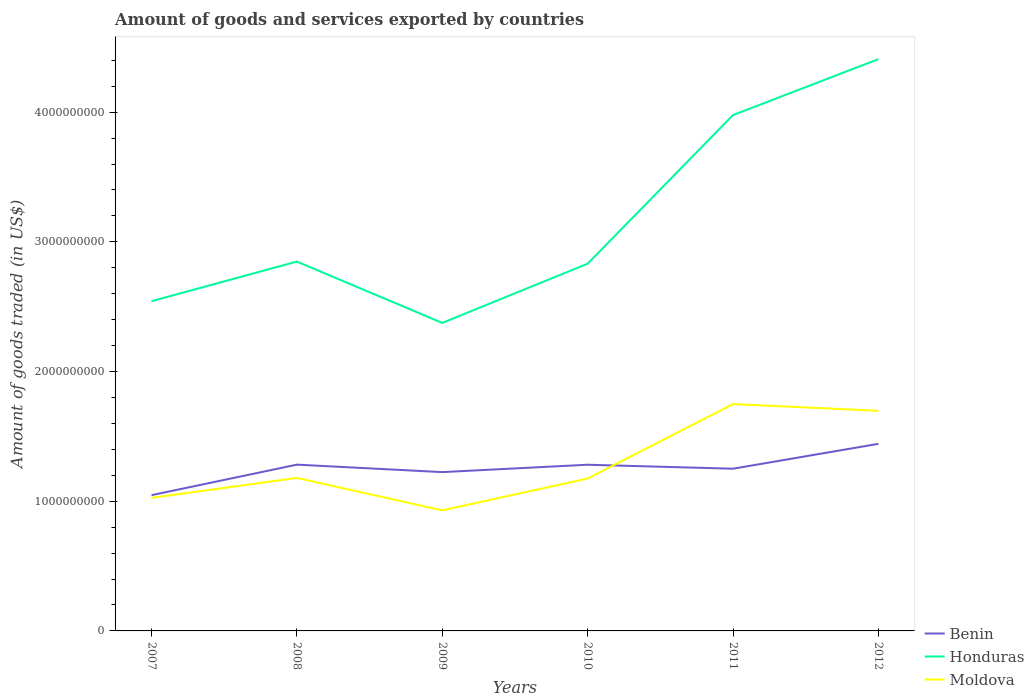How many different coloured lines are there?
Your answer should be compact. 3. Is the number of lines equal to the number of legend labels?
Provide a succinct answer. Yes. Across all years, what is the maximum total amount of goods and services exported in Benin?
Keep it short and to the point. 1.05e+09. In which year was the total amount of goods and services exported in Benin maximum?
Your answer should be very brief. 2007. What is the total total amount of goods and services exported in Moldova in the graph?
Provide a succinct answer. -2.45e+08. What is the difference between the highest and the second highest total amount of goods and services exported in Moldova?
Make the answer very short. 8.20e+08. What is the difference between the highest and the lowest total amount of goods and services exported in Moldova?
Make the answer very short. 2. How many lines are there?
Make the answer very short. 3. How many years are there in the graph?
Make the answer very short. 6. What is the difference between two consecutive major ticks on the Y-axis?
Your answer should be very brief. 1.00e+09. Where does the legend appear in the graph?
Your answer should be compact. Bottom right. How many legend labels are there?
Keep it short and to the point. 3. How are the legend labels stacked?
Make the answer very short. Vertical. What is the title of the graph?
Provide a succinct answer. Amount of goods and services exported by countries. What is the label or title of the X-axis?
Make the answer very short. Years. What is the label or title of the Y-axis?
Provide a succinct answer. Amount of goods traded (in US$). What is the Amount of goods traded (in US$) in Benin in 2007?
Keep it short and to the point. 1.05e+09. What is the Amount of goods traded (in US$) in Honduras in 2007?
Your answer should be very brief. 2.54e+09. What is the Amount of goods traded (in US$) in Moldova in 2007?
Give a very brief answer. 1.03e+09. What is the Amount of goods traded (in US$) of Benin in 2008?
Provide a succinct answer. 1.28e+09. What is the Amount of goods traded (in US$) in Honduras in 2008?
Make the answer very short. 2.85e+09. What is the Amount of goods traded (in US$) of Moldova in 2008?
Make the answer very short. 1.18e+09. What is the Amount of goods traded (in US$) in Benin in 2009?
Your answer should be compact. 1.22e+09. What is the Amount of goods traded (in US$) of Honduras in 2009?
Offer a terse response. 2.38e+09. What is the Amount of goods traded (in US$) of Moldova in 2009?
Make the answer very short. 9.30e+08. What is the Amount of goods traded (in US$) in Benin in 2010?
Your answer should be very brief. 1.28e+09. What is the Amount of goods traded (in US$) in Honduras in 2010?
Ensure brevity in your answer.  2.83e+09. What is the Amount of goods traded (in US$) of Moldova in 2010?
Your response must be concise. 1.18e+09. What is the Amount of goods traded (in US$) of Benin in 2011?
Provide a succinct answer. 1.25e+09. What is the Amount of goods traded (in US$) in Honduras in 2011?
Give a very brief answer. 3.98e+09. What is the Amount of goods traded (in US$) of Moldova in 2011?
Offer a terse response. 1.75e+09. What is the Amount of goods traded (in US$) of Benin in 2012?
Your response must be concise. 1.44e+09. What is the Amount of goods traded (in US$) of Honduras in 2012?
Offer a very short reply. 4.41e+09. What is the Amount of goods traded (in US$) of Moldova in 2012?
Offer a very short reply. 1.70e+09. Across all years, what is the maximum Amount of goods traded (in US$) of Benin?
Provide a succinct answer. 1.44e+09. Across all years, what is the maximum Amount of goods traded (in US$) in Honduras?
Ensure brevity in your answer.  4.41e+09. Across all years, what is the maximum Amount of goods traded (in US$) of Moldova?
Your answer should be compact. 1.75e+09. Across all years, what is the minimum Amount of goods traded (in US$) in Benin?
Your answer should be compact. 1.05e+09. Across all years, what is the minimum Amount of goods traded (in US$) of Honduras?
Keep it short and to the point. 2.38e+09. Across all years, what is the minimum Amount of goods traded (in US$) of Moldova?
Ensure brevity in your answer.  9.30e+08. What is the total Amount of goods traded (in US$) of Benin in the graph?
Your response must be concise. 7.53e+09. What is the total Amount of goods traded (in US$) of Honduras in the graph?
Provide a short and direct response. 1.90e+1. What is the total Amount of goods traded (in US$) in Moldova in the graph?
Keep it short and to the point. 7.76e+09. What is the difference between the Amount of goods traded (in US$) of Benin in 2007 and that in 2008?
Your answer should be very brief. -2.35e+08. What is the difference between the Amount of goods traded (in US$) of Honduras in 2007 and that in 2008?
Your answer should be very brief. -3.05e+08. What is the difference between the Amount of goods traded (in US$) in Moldova in 2007 and that in 2008?
Your answer should be compact. -1.54e+08. What is the difference between the Amount of goods traded (in US$) of Benin in 2007 and that in 2009?
Provide a short and direct response. -1.78e+08. What is the difference between the Amount of goods traded (in US$) in Honduras in 2007 and that in 2009?
Give a very brief answer. 1.68e+08. What is the difference between the Amount of goods traded (in US$) of Moldova in 2007 and that in 2009?
Your answer should be very brief. 9.62e+07. What is the difference between the Amount of goods traded (in US$) of Benin in 2007 and that in 2010?
Make the answer very short. -2.35e+08. What is the difference between the Amount of goods traded (in US$) of Honduras in 2007 and that in 2010?
Ensure brevity in your answer.  -2.89e+08. What is the difference between the Amount of goods traded (in US$) in Moldova in 2007 and that in 2010?
Make the answer very short. -1.49e+08. What is the difference between the Amount of goods traded (in US$) in Benin in 2007 and that in 2011?
Your answer should be compact. -2.04e+08. What is the difference between the Amount of goods traded (in US$) of Honduras in 2007 and that in 2011?
Offer a terse response. -1.43e+09. What is the difference between the Amount of goods traded (in US$) of Moldova in 2007 and that in 2011?
Ensure brevity in your answer.  -7.23e+08. What is the difference between the Amount of goods traded (in US$) in Benin in 2007 and that in 2012?
Your answer should be compact. -3.96e+08. What is the difference between the Amount of goods traded (in US$) of Honduras in 2007 and that in 2012?
Ensure brevity in your answer.  -1.87e+09. What is the difference between the Amount of goods traded (in US$) of Moldova in 2007 and that in 2012?
Provide a short and direct response. -6.71e+08. What is the difference between the Amount of goods traded (in US$) in Benin in 2008 and that in 2009?
Your answer should be very brief. 5.76e+07. What is the difference between the Amount of goods traded (in US$) in Honduras in 2008 and that in 2009?
Your answer should be very brief. 4.73e+08. What is the difference between the Amount of goods traded (in US$) of Moldova in 2008 and that in 2009?
Offer a terse response. 2.50e+08. What is the difference between the Amount of goods traded (in US$) in Benin in 2008 and that in 2010?
Provide a succinct answer. 6.49e+05. What is the difference between the Amount of goods traded (in US$) in Honduras in 2008 and that in 2010?
Make the answer very short. 1.64e+07. What is the difference between the Amount of goods traded (in US$) in Moldova in 2008 and that in 2010?
Offer a terse response. 4.72e+06. What is the difference between the Amount of goods traded (in US$) in Benin in 2008 and that in 2011?
Provide a short and direct response. 3.14e+07. What is the difference between the Amount of goods traded (in US$) in Honduras in 2008 and that in 2011?
Your response must be concise. -1.13e+09. What is the difference between the Amount of goods traded (in US$) of Moldova in 2008 and that in 2011?
Give a very brief answer. -5.70e+08. What is the difference between the Amount of goods traded (in US$) in Benin in 2008 and that in 2012?
Provide a succinct answer. -1.60e+08. What is the difference between the Amount of goods traded (in US$) of Honduras in 2008 and that in 2012?
Keep it short and to the point. -1.56e+09. What is the difference between the Amount of goods traded (in US$) of Moldova in 2008 and that in 2012?
Offer a very short reply. -5.18e+08. What is the difference between the Amount of goods traded (in US$) of Benin in 2009 and that in 2010?
Provide a short and direct response. -5.70e+07. What is the difference between the Amount of goods traded (in US$) of Honduras in 2009 and that in 2010?
Offer a very short reply. -4.57e+08. What is the difference between the Amount of goods traded (in US$) of Moldova in 2009 and that in 2010?
Keep it short and to the point. -2.45e+08. What is the difference between the Amount of goods traded (in US$) of Benin in 2009 and that in 2011?
Make the answer very short. -2.62e+07. What is the difference between the Amount of goods traded (in US$) in Honduras in 2009 and that in 2011?
Your response must be concise. -1.60e+09. What is the difference between the Amount of goods traded (in US$) in Moldova in 2009 and that in 2011?
Your answer should be very brief. -8.20e+08. What is the difference between the Amount of goods traded (in US$) in Benin in 2009 and that in 2012?
Make the answer very short. -2.18e+08. What is the difference between the Amount of goods traded (in US$) of Honduras in 2009 and that in 2012?
Give a very brief answer. -2.03e+09. What is the difference between the Amount of goods traded (in US$) in Moldova in 2009 and that in 2012?
Give a very brief answer. -7.67e+08. What is the difference between the Amount of goods traded (in US$) of Benin in 2010 and that in 2011?
Keep it short and to the point. 3.07e+07. What is the difference between the Amount of goods traded (in US$) of Honduras in 2010 and that in 2011?
Keep it short and to the point. -1.15e+09. What is the difference between the Amount of goods traded (in US$) in Moldova in 2010 and that in 2011?
Provide a short and direct response. -5.74e+08. What is the difference between the Amount of goods traded (in US$) in Benin in 2010 and that in 2012?
Offer a terse response. -1.61e+08. What is the difference between the Amount of goods traded (in US$) in Honduras in 2010 and that in 2012?
Offer a terse response. -1.58e+09. What is the difference between the Amount of goods traded (in US$) in Moldova in 2010 and that in 2012?
Ensure brevity in your answer.  -5.22e+08. What is the difference between the Amount of goods traded (in US$) of Benin in 2011 and that in 2012?
Offer a very short reply. -1.92e+08. What is the difference between the Amount of goods traded (in US$) in Honduras in 2011 and that in 2012?
Keep it short and to the point. -4.32e+08. What is the difference between the Amount of goods traded (in US$) in Moldova in 2011 and that in 2012?
Give a very brief answer. 5.22e+07. What is the difference between the Amount of goods traded (in US$) of Benin in 2007 and the Amount of goods traded (in US$) of Honduras in 2008?
Keep it short and to the point. -1.80e+09. What is the difference between the Amount of goods traded (in US$) in Benin in 2007 and the Amount of goods traded (in US$) in Moldova in 2008?
Make the answer very short. -1.33e+08. What is the difference between the Amount of goods traded (in US$) of Honduras in 2007 and the Amount of goods traded (in US$) of Moldova in 2008?
Your answer should be compact. 1.36e+09. What is the difference between the Amount of goods traded (in US$) of Benin in 2007 and the Amount of goods traded (in US$) of Honduras in 2009?
Your answer should be compact. -1.33e+09. What is the difference between the Amount of goods traded (in US$) in Benin in 2007 and the Amount of goods traded (in US$) in Moldova in 2009?
Offer a very short reply. 1.17e+08. What is the difference between the Amount of goods traded (in US$) of Honduras in 2007 and the Amount of goods traded (in US$) of Moldova in 2009?
Ensure brevity in your answer.  1.61e+09. What is the difference between the Amount of goods traded (in US$) in Benin in 2007 and the Amount of goods traded (in US$) in Honduras in 2010?
Give a very brief answer. -1.78e+09. What is the difference between the Amount of goods traded (in US$) of Benin in 2007 and the Amount of goods traded (in US$) of Moldova in 2010?
Your answer should be compact. -1.28e+08. What is the difference between the Amount of goods traded (in US$) in Honduras in 2007 and the Amount of goods traded (in US$) in Moldova in 2010?
Keep it short and to the point. 1.37e+09. What is the difference between the Amount of goods traded (in US$) of Benin in 2007 and the Amount of goods traded (in US$) of Honduras in 2011?
Give a very brief answer. -2.93e+09. What is the difference between the Amount of goods traded (in US$) in Benin in 2007 and the Amount of goods traded (in US$) in Moldova in 2011?
Make the answer very short. -7.03e+08. What is the difference between the Amount of goods traded (in US$) in Honduras in 2007 and the Amount of goods traded (in US$) in Moldova in 2011?
Provide a succinct answer. 7.93e+08. What is the difference between the Amount of goods traded (in US$) of Benin in 2007 and the Amount of goods traded (in US$) of Honduras in 2012?
Offer a very short reply. -3.36e+09. What is the difference between the Amount of goods traded (in US$) in Benin in 2007 and the Amount of goods traded (in US$) in Moldova in 2012?
Your answer should be very brief. -6.51e+08. What is the difference between the Amount of goods traded (in US$) of Honduras in 2007 and the Amount of goods traded (in US$) of Moldova in 2012?
Provide a succinct answer. 8.45e+08. What is the difference between the Amount of goods traded (in US$) in Benin in 2008 and the Amount of goods traded (in US$) in Honduras in 2009?
Provide a succinct answer. -1.09e+09. What is the difference between the Amount of goods traded (in US$) of Benin in 2008 and the Amount of goods traded (in US$) of Moldova in 2009?
Keep it short and to the point. 3.52e+08. What is the difference between the Amount of goods traded (in US$) of Honduras in 2008 and the Amount of goods traded (in US$) of Moldova in 2009?
Make the answer very short. 1.92e+09. What is the difference between the Amount of goods traded (in US$) in Benin in 2008 and the Amount of goods traded (in US$) in Honduras in 2010?
Your answer should be very brief. -1.55e+09. What is the difference between the Amount of goods traded (in US$) of Benin in 2008 and the Amount of goods traded (in US$) of Moldova in 2010?
Make the answer very short. 1.07e+08. What is the difference between the Amount of goods traded (in US$) of Honduras in 2008 and the Amount of goods traded (in US$) of Moldova in 2010?
Provide a succinct answer. 1.67e+09. What is the difference between the Amount of goods traded (in US$) in Benin in 2008 and the Amount of goods traded (in US$) in Honduras in 2011?
Keep it short and to the point. -2.70e+09. What is the difference between the Amount of goods traded (in US$) in Benin in 2008 and the Amount of goods traded (in US$) in Moldova in 2011?
Provide a succinct answer. -4.67e+08. What is the difference between the Amount of goods traded (in US$) of Honduras in 2008 and the Amount of goods traded (in US$) of Moldova in 2011?
Provide a short and direct response. 1.10e+09. What is the difference between the Amount of goods traded (in US$) of Benin in 2008 and the Amount of goods traded (in US$) of Honduras in 2012?
Make the answer very short. -3.13e+09. What is the difference between the Amount of goods traded (in US$) of Benin in 2008 and the Amount of goods traded (in US$) of Moldova in 2012?
Your response must be concise. -4.15e+08. What is the difference between the Amount of goods traded (in US$) in Honduras in 2008 and the Amount of goods traded (in US$) in Moldova in 2012?
Your answer should be compact. 1.15e+09. What is the difference between the Amount of goods traded (in US$) of Benin in 2009 and the Amount of goods traded (in US$) of Honduras in 2010?
Your answer should be compact. -1.61e+09. What is the difference between the Amount of goods traded (in US$) of Benin in 2009 and the Amount of goods traded (in US$) of Moldova in 2010?
Ensure brevity in your answer.  4.96e+07. What is the difference between the Amount of goods traded (in US$) in Honduras in 2009 and the Amount of goods traded (in US$) in Moldova in 2010?
Your answer should be compact. 1.20e+09. What is the difference between the Amount of goods traded (in US$) in Benin in 2009 and the Amount of goods traded (in US$) in Honduras in 2011?
Ensure brevity in your answer.  -2.75e+09. What is the difference between the Amount of goods traded (in US$) of Benin in 2009 and the Amount of goods traded (in US$) of Moldova in 2011?
Your answer should be compact. -5.25e+08. What is the difference between the Amount of goods traded (in US$) in Honduras in 2009 and the Amount of goods traded (in US$) in Moldova in 2011?
Provide a short and direct response. 6.26e+08. What is the difference between the Amount of goods traded (in US$) in Benin in 2009 and the Amount of goods traded (in US$) in Honduras in 2012?
Your answer should be very brief. -3.18e+09. What is the difference between the Amount of goods traded (in US$) in Benin in 2009 and the Amount of goods traded (in US$) in Moldova in 2012?
Offer a terse response. -4.73e+08. What is the difference between the Amount of goods traded (in US$) of Honduras in 2009 and the Amount of goods traded (in US$) of Moldova in 2012?
Your answer should be very brief. 6.78e+08. What is the difference between the Amount of goods traded (in US$) in Benin in 2010 and the Amount of goods traded (in US$) in Honduras in 2011?
Offer a very short reply. -2.70e+09. What is the difference between the Amount of goods traded (in US$) of Benin in 2010 and the Amount of goods traded (in US$) of Moldova in 2011?
Give a very brief answer. -4.68e+08. What is the difference between the Amount of goods traded (in US$) in Honduras in 2010 and the Amount of goods traded (in US$) in Moldova in 2011?
Provide a succinct answer. 1.08e+09. What is the difference between the Amount of goods traded (in US$) of Benin in 2010 and the Amount of goods traded (in US$) of Honduras in 2012?
Your response must be concise. -3.13e+09. What is the difference between the Amount of goods traded (in US$) of Benin in 2010 and the Amount of goods traded (in US$) of Moldova in 2012?
Offer a terse response. -4.16e+08. What is the difference between the Amount of goods traded (in US$) of Honduras in 2010 and the Amount of goods traded (in US$) of Moldova in 2012?
Keep it short and to the point. 1.13e+09. What is the difference between the Amount of goods traded (in US$) in Benin in 2011 and the Amount of goods traded (in US$) in Honduras in 2012?
Give a very brief answer. -3.16e+09. What is the difference between the Amount of goods traded (in US$) of Benin in 2011 and the Amount of goods traded (in US$) of Moldova in 2012?
Provide a succinct answer. -4.46e+08. What is the difference between the Amount of goods traded (in US$) in Honduras in 2011 and the Amount of goods traded (in US$) in Moldova in 2012?
Make the answer very short. 2.28e+09. What is the average Amount of goods traded (in US$) of Benin per year?
Ensure brevity in your answer.  1.25e+09. What is the average Amount of goods traded (in US$) of Honduras per year?
Give a very brief answer. 3.16e+09. What is the average Amount of goods traded (in US$) in Moldova per year?
Your response must be concise. 1.29e+09. In the year 2007, what is the difference between the Amount of goods traded (in US$) in Benin and Amount of goods traded (in US$) in Honduras?
Provide a succinct answer. -1.50e+09. In the year 2007, what is the difference between the Amount of goods traded (in US$) in Benin and Amount of goods traded (in US$) in Moldova?
Offer a very short reply. 2.08e+07. In the year 2007, what is the difference between the Amount of goods traded (in US$) of Honduras and Amount of goods traded (in US$) of Moldova?
Make the answer very short. 1.52e+09. In the year 2008, what is the difference between the Amount of goods traded (in US$) of Benin and Amount of goods traded (in US$) of Honduras?
Ensure brevity in your answer.  -1.57e+09. In the year 2008, what is the difference between the Amount of goods traded (in US$) of Benin and Amount of goods traded (in US$) of Moldova?
Provide a short and direct response. 1.02e+08. In the year 2008, what is the difference between the Amount of goods traded (in US$) of Honduras and Amount of goods traded (in US$) of Moldova?
Provide a short and direct response. 1.67e+09. In the year 2009, what is the difference between the Amount of goods traded (in US$) of Benin and Amount of goods traded (in US$) of Honduras?
Ensure brevity in your answer.  -1.15e+09. In the year 2009, what is the difference between the Amount of goods traded (in US$) in Benin and Amount of goods traded (in US$) in Moldova?
Provide a short and direct response. 2.95e+08. In the year 2009, what is the difference between the Amount of goods traded (in US$) in Honduras and Amount of goods traded (in US$) in Moldova?
Keep it short and to the point. 1.45e+09. In the year 2010, what is the difference between the Amount of goods traded (in US$) in Benin and Amount of goods traded (in US$) in Honduras?
Provide a succinct answer. -1.55e+09. In the year 2010, what is the difference between the Amount of goods traded (in US$) in Benin and Amount of goods traded (in US$) in Moldova?
Give a very brief answer. 1.07e+08. In the year 2010, what is the difference between the Amount of goods traded (in US$) of Honduras and Amount of goods traded (in US$) of Moldova?
Provide a short and direct response. 1.66e+09. In the year 2011, what is the difference between the Amount of goods traded (in US$) of Benin and Amount of goods traded (in US$) of Honduras?
Ensure brevity in your answer.  -2.73e+09. In the year 2011, what is the difference between the Amount of goods traded (in US$) in Benin and Amount of goods traded (in US$) in Moldova?
Provide a succinct answer. -4.99e+08. In the year 2011, what is the difference between the Amount of goods traded (in US$) in Honduras and Amount of goods traded (in US$) in Moldova?
Provide a succinct answer. 2.23e+09. In the year 2012, what is the difference between the Amount of goods traded (in US$) of Benin and Amount of goods traded (in US$) of Honduras?
Your answer should be very brief. -2.97e+09. In the year 2012, what is the difference between the Amount of goods traded (in US$) in Benin and Amount of goods traded (in US$) in Moldova?
Provide a short and direct response. -2.55e+08. In the year 2012, what is the difference between the Amount of goods traded (in US$) of Honduras and Amount of goods traded (in US$) of Moldova?
Make the answer very short. 2.71e+09. What is the ratio of the Amount of goods traded (in US$) in Benin in 2007 to that in 2008?
Make the answer very short. 0.82. What is the ratio of the Amount of goods traded (in US$) in Honduras in 2007 to that in 2008?
Your answer should be very brief. 0.89. What is the ratio of the Amount of goods traded (in US$) in Moldova in 2007 to that in 2008?
Offer a very short reply. 0.87. What is the ratio of the Amount of goods traded (in US$) of Benin in 2007 to that in 2009?
Offer a terse response. 0.85. What is the ratio of the Amount of goods traded (in US$) in Honduras in 2007 to that in 2009?
Offer a very short reply. 1.07. What is the ratio of the Amount of goods traded (in US$) of Moldova in 2007 to that in 2009?
Your answer should be very brief. 1.1. What is the ratio of the Amount of goods traded (in US$) in Benin in 2007 to that in 2010?
Provide a succinct answer. 0.82. What is the ratio of the Amount of goods traded (in US$) of Honduras in 2007 to that in 2010?
Keep it short and to the point. 0.9. What is the ratio of the Amount of goods traded (in US$) of Moldova in 2007 to that in 2010?
Provide a short and direct response. 0.87. What is the ratio of the Amount of goods traded (in US$) of Benin in 2007 to that in 2011?
Give a very brief answer. 0.84. What is the ratio of the Amount of goods traded (in US$) of Honduras in 2007 to that in 2011?
Your response must be concise. 0.64. What is the ratio of the Amount of goods traded (in US$) in Moldova in 2007 to that in 2011?
Provide a short and direct response. 0.59. What is the ratio of the Amount of goods traded (in US$) of Benin in 2007 to that in 2012?
Offer a terse response. 0.73. What is the ratio of the Amount of goods traded (in US$) in Honduras in 2007 to that in 2012?
Your answer should be very brief. 0.58. What is the ratio of the Amount of goods traded (in US$) of Moldova in 2007 to that in 2012?
Provide a succinct answer. 0.6. What is the ratio of the Amount of goods traded (in US$) of Benin in 2008 to that in 2009?
Your answer should be very brief. 1.05. What is the ratio of the Amount of goods traded (in US$) in Honduras in 2008 to that in 2009?
Your answer should be very brief. 1.2. What is the ratio of the Amount of goods traded (in US$) in Moldova in 2008 to that in 2009?
Offer a very short reply. 1.27. What is the ratio of the Amount of goods traded (in US$) in Benin in 2008 to that in 2010?
Give a very brief answer. 1. What is the ratio of the Amount of goods traded (in US$) of Honduras in 2008 to that in 2010?
Make the answer very short. 1.01. What is the ratio of the Amount of goods traded (in US$) in Benin in 2008 to that in 2011?
Keep it short and to the point. 1.03. What is the ratio of the Amount of goods traded (in US$) in Honduras in 2008 to that in 2011?
Offer a terse response. 0.72. What is the ratio of the Amount of goods traded (in US$) in Moldova in 2008 to that in 2011?
Ensure brevity in your answer.  0.67. What is the ratio of the Amount of goods traded (in US$) of Benin in 2008 to that in 2012?
Offer a terse response. 0.89. What is the ratio of the Amount of goods traded (in US$) in Honduras in 2008 to that in 2012?
Make the answer very short. 0.65. What is the ratio of the Amount of goods traded (in US$) in Moldova in 2008 to that in 2012?
Provide a short and direct response. 0.7. What is the ratio of the Amount of goods traded (in US$) of Benin in 2009 to that in 2010?
Your response must be concise. 0.96. What is the ratio of the Amount of goods traded (in US$) in Honduras in 2009 to that in 2010?
Provide a short and direct response. 0.84. What is the ratio of the Amount of goods traded (in US$) of Moldova in 2009 to that in 2010?
Keep it short and to the point. 0.79. What is the ratio of the Amount of goods traded (in US$) in Benin in 2009 to that in 2011?
Your answer should be very brief. 0.98. What is the ratio of the Amount of goods traded (in US$) in Honduras in 2009 to that in 2011?
Provide a succinct answer. 0.6. What is the ratio of the Amount of goods traded (in US$) of Moldova in 2009 to that in 2011?
Make the answer very short. 0.53. What is the ratio of the Amount of goods traded (in US$) of Benin in 2009 to that in 2012?
Keep it short and to the point. 0.85. What is the ratio of the Amount of goods traded (in US$) of Honduras in 2009 to that in 2012?
Keep it short and to the point. 0.54. What is the ratio of the Amount of goods traded (in US$) in Moldova in 2009 to that in 2012?
Provide a short and direct response. 0.55. What is the ratio of the Amount of goods traded (in US$) in Benin in 2010 to that in 2011?
Your answer should be very brief. 1.02. What is the ratio of the Amount of goods traded (in US$) of Honduras in 2010 to that in 2011?
Make the answer very short. 0.71. What is the ratio of the Amount of goods traded (in US$) in Moldova in 2010 to that in 2011?
Your answer should be very brief. 0.67. What is the ratio of the Amount of goods traded (in US$) of Benin in 2010 to that in 2012?
Keep it short and to the point. 0.89. What is the ratio of the Amount of goods traded (in US$) of Honduras in 2010 to that in 2012?
Offer a very short reply. 0.64. What is the ratio of the Amount of goods traded (in US$) in Moldova in 2010 to that in 2012?
Make the answer very short. 0.69. What is the ratio of the Amount of goods traded (in US$) of Benin in 2011 to that in 2012?
Give a very brief answer. 0.87. What is the ratio of the Amount of goods traded (in US$) of Honduras in 2011 to that in 2012?
Make the answer very short. 0.9. What is the ratio of the Amount of goods traded (in US$) in Moldova in 2011 to that in 2012?
Your response must be concise. 1.03. What is the difference between the highest and the second highest Amount of goods traded (in US$) of Benin?
Ensure brevity in your answer.  1.60e+08. What is the difference between the highest and the second highest Amount of goods traded (in US$) in Honduras?
Your answer should be compact. 4.32e+08. What is the difference between the highest and the second highest Amount of goods traded (in US$) in Moldova?
Your answer should be very brief. 5.22e+07. What is the difference between the highest and the lowest Amount of goods traded (in US$) in Benin?
Your response must be concise. 3.96e+08. What is the difference between the highest and the lowest Amount of goods traded (in US$) of Honduras?
Keep it short and to the point. 2.03e+09. What is the difference between the highest and the lowest Amount of goods traded (in US$) of Moldova?
Provide a succinct answer. 8.20e+08. 